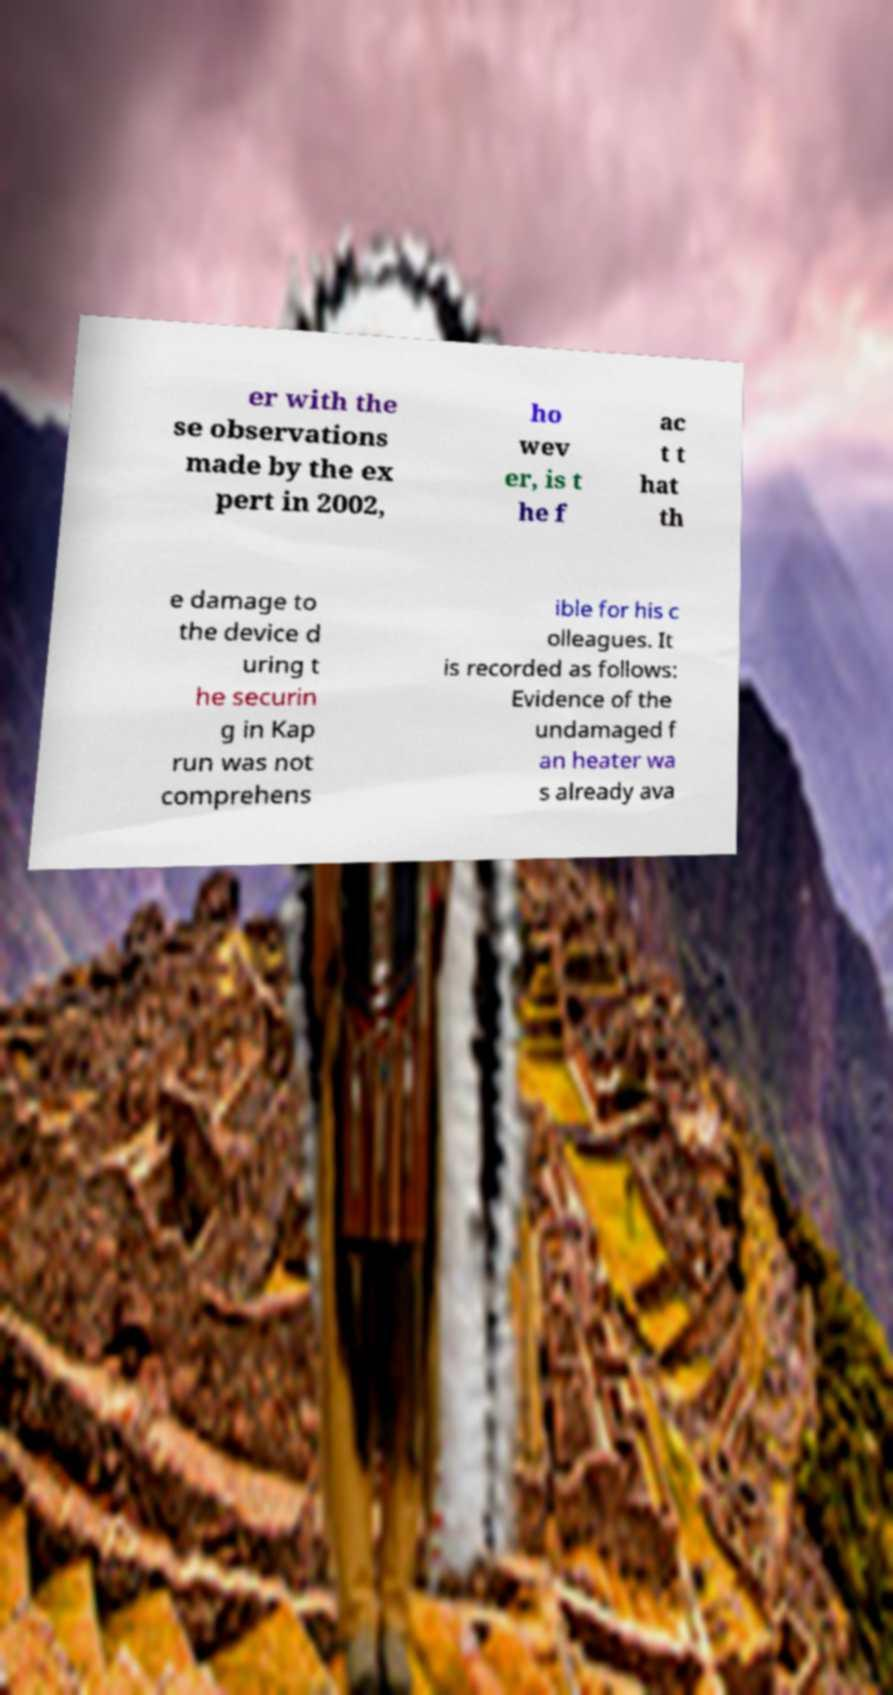Could you assist in decoding the text presented in this image and type it out clearly? er with the se observations made by the ex pert in 2002, ho wev er, is t he f ac t t hat th e damage to the device d uring t he securin g in Kap run was not comprehens ible for his c olleagues. It is recorded as follows: Evidence of the undamaged f an heater wa s already ava 